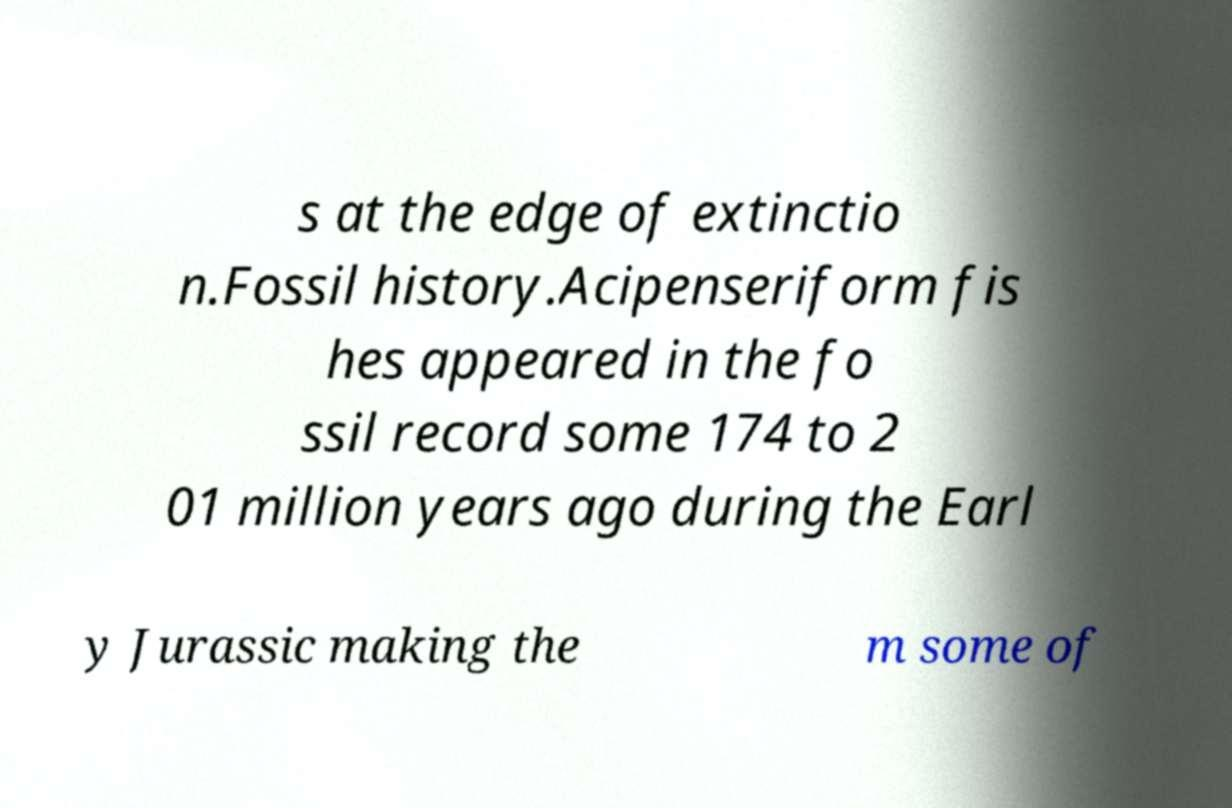There's text embedded in this image that I need extracted. Can you transcribe it verbatim? s at the edge of extinctio n.Fossil history.Acipenseriform fis hes appeared in the fo ssil record some 174 to 2 01 million years ago during the Earl y Jurassic making the m some of 